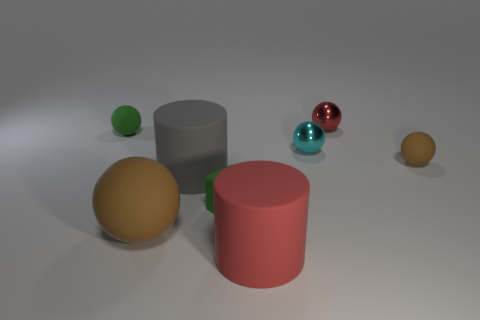Are there more big gray matte things than small red matte balls?
Ensure brevity in your answer.  Yes. Do the small green ball and the green block have the same material?
Offer a terse response. Yes. Are there any other things that are made of the same material as the large red thing?
Your answer should be compact. Yes. Is the number of spheres that are behind the tiny cyan shiny thing greater than the number of big brown rubber objects?
Your response must be concise. Yes. How many other red metal objects have the same shape as the tiny red shiny thing?
Provide a succinct answer. 0. What size is the green block that is the same material as the tiny brown thing?
Make the answer very short. Small. There is a rubber thing that is both on the left side of the big gray rubber thing and in front of the big gray rubber cylinder; what color is it?
Give a very brief answer. Brown. What number of purple blocks have the same size as the red cylinder?
Your answer should be compact. 0. There is another ball that is the same color as the big ball; what size is it?
Your response must be concise. Small. There is a matte object that is left of the block and on the right side of the large brown ball; what is its size?
Ensure brevity in your answer.  Large. 